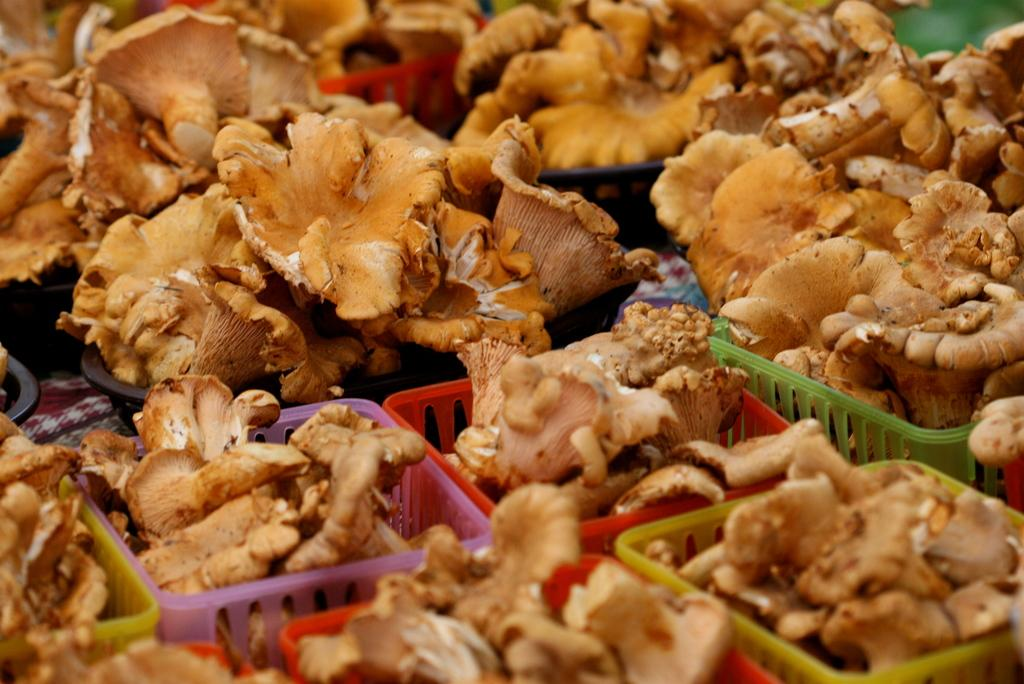What type of items are in the image? There are vegetables baskets in the image. Where are the baskets located? The baskets are kept on the floor. Can you describe the setting of the image? The image may have been taken in a market. What type of chair is the donkey sitting on in the image? There is no donkey or chair present in the image. 